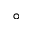Convert formula to latex. <formula><loc_0><loc_0><loc_500><loc_500>\circ</formula> 